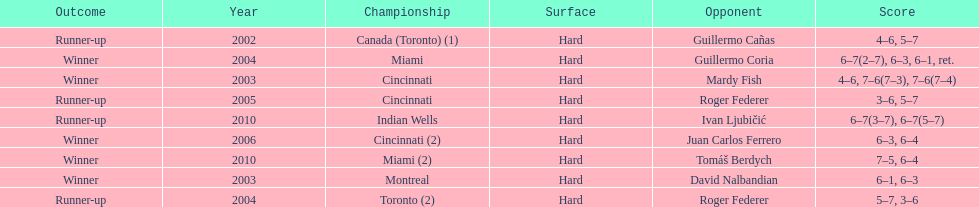How many championships occurred in toronto or montreal? 3. 